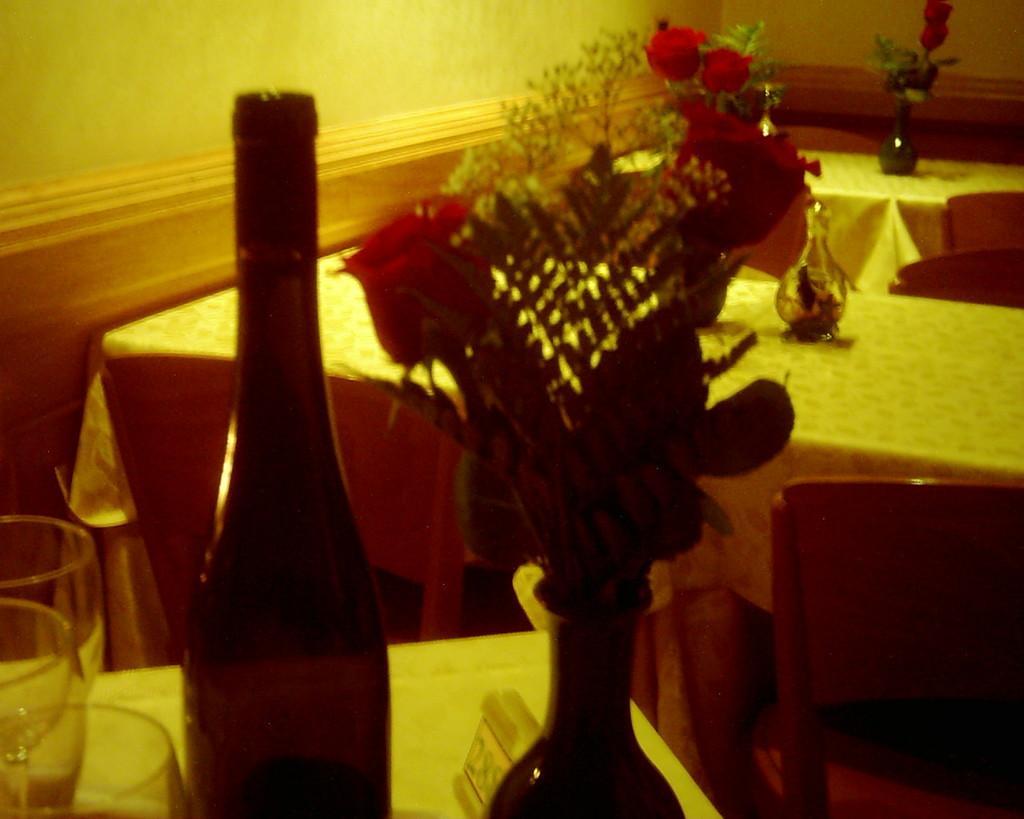In one or two sentences, can you explain what this image depicts? In this picture there are tables and chairs. On this tables there are flower vase with flowers, bottle and glasses. 